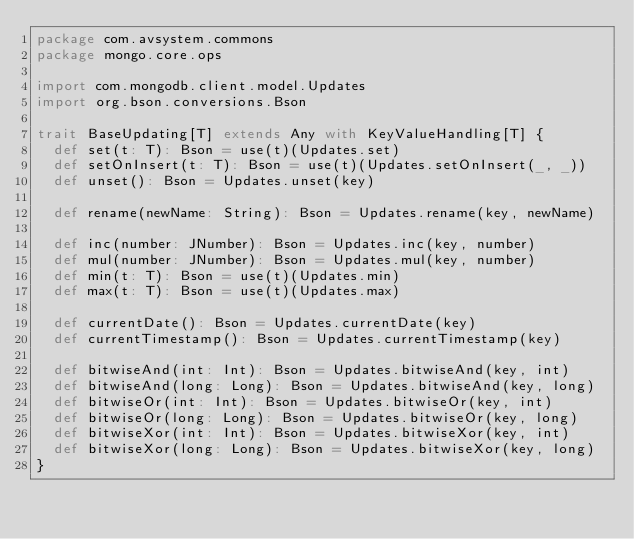Convert code to text. <code><loc_0><loc_0><loc_500><loc_500><_Scala_>package com.avsystem.commons
package mongo.core.ops

import com.mongodb.client.model.Updates
import org.bson.conversions.Bson

trait BaseUpdating[T] extends Any with KeyValueHandling[T] {
  def set(t: T): Bson = use(t)(Updates.set)
  def setOnInsert(t: T): Bson = use(t)(Updates.setOnInsert(_, _))
  def unset(): Bson = Updates.unset(key)

  def rename(newName: String): Bson = Updates.rename(key, newName)

  def inc(number: JNumber): Bson = Updates.inc(key, number)
  def mul(number: JNumber): Bson = Updates.mul(key, number)
  def min(t: T): Bson = use(t)(Updates.min)
  def max(t: T): Bson = use(t)(Updates.max)

  def currentDate(): Bson = Updates.currentDate(key)
  def currentTimestamp(): Bson = Updates.currentTimestamp(key)

  def bitwiseAnd(int: Int): Bson = Updates.bitwiseAnd(key, int)
  def bitwiseAnd(long: Long): Bson = Updates.bitwiseAnd(key, long)
  def bitwiseOr(int: Int): Bson = Updates.bitwiseOr(key, int)
  def bitwiseOr(long: Long): Bson = Updates.bitwiseOr(key, long)
  def bitwiseXor(int: Int): Bson = Updates.bitwiseXor(key, int)
  def bitwiseXor(long: Long): Bson = Updates.bitwiseXor(key, long)
}
</code> 